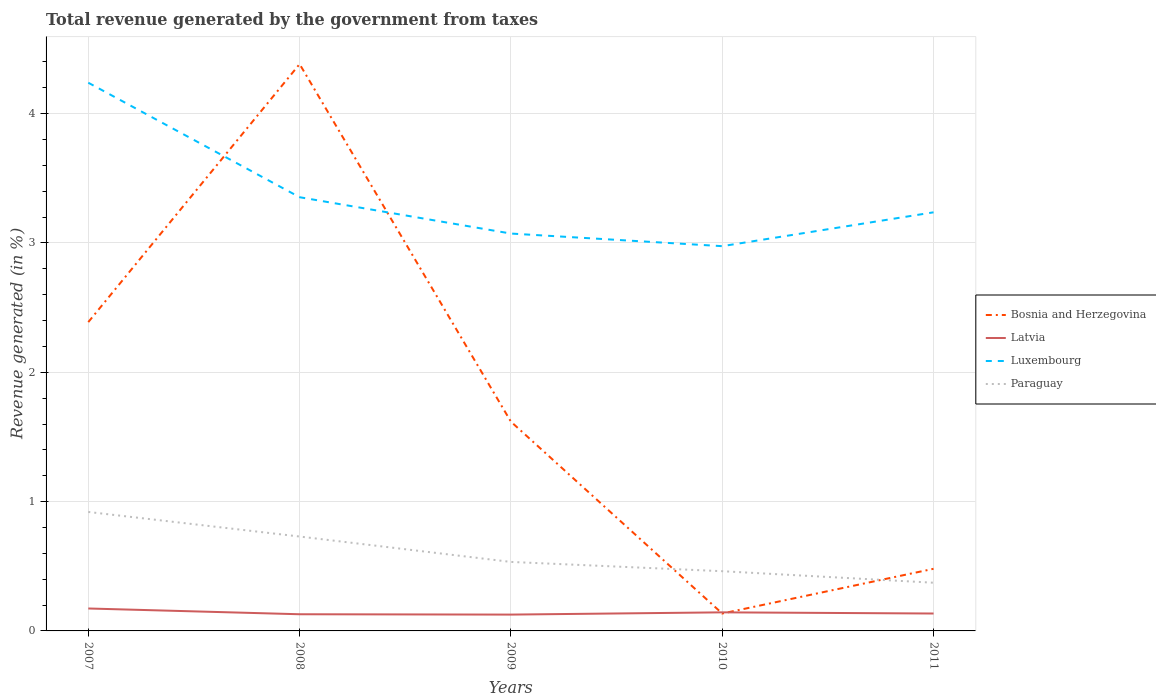Does the line corresponding to Luxembourg intersect with the line corresponding to Bosnia and Herzegovina?
Make the answer very short. Yes. Is the number of lines equal to the number of legend labels?
Ensure brevity in your answer.  Yes. Across all years, what is the maximum total revenue generated in Paraguay?
Ensure brevity in your answer.  0.37. What is the total total revenue generated in Latvia in the graph?
Provide a short and direct response. 0.04. What is the difference between the highest and the second highest total revenue generated in Latvia?
Your answer should be compact. 0.05. What is the difference between the highest and the lowest total revenue generated in Paraguay?
Ensure brevity in your answer.  2. Is the total revenue generated in Latvia strictly greater than the total revenue generated in Paraguay over the years?
Your answer should be very brief. Yes. How many lines are there?
Your response must be concise. 4. What is the difference between two consecutive major ticks on the Y-axis?
Your response must be concise. 1. Does the graph contain any zero values?
Your answer should be compact. No. Does the graph contain grids?
Provide a succinct answer. Yes. How many legend labels are there?
Offer a terse response. 4. How are the legend labels stacked?
Give a very brief answer. Vertical. What is the title of the graph?
Your answer should be very brief. Total revenue generated by the government from taxes. What is the label or title of the X-axis?
Keep it short and to the point. Years. What is the label or title of the Y-axis?
Your answer should be very brief. Revenue generated (in %). What is the Revenue generated (in %) of Bosnia and Herzegovina in 2007?
Provide a succinct answer. 2.39. What is the Revenue generated (in %) of Latvia in 2007?
Offer a terse response. 0.17. What is the Revenue generated (in %) of Luxembourg in 2007?
Provide a succinct answer. 4.24. What is the Revenue generated (in %) in Paraguay in 2007?
Your answer should be very brief. 0.92. What is the Revenue generated (in %) in Bosnia and Herzegovina in 2008?
Your response must be concise. 4.38. What is the Revenue generated (in %) of Latvia in 2008?
Keep it short and to the point. 0.13. What is the Revenue generated (in %) in Luxembourg in 2008?
Your answer should be compact. 3.35. What is the Revenue generated (in %) in Paraguay in 2008?
Provide a succinct answer. 0.73. What is the Revenue generated (in %) in Bosnia and Herzegovina in 2009?
Offer a very short reply. 1.62. What is the Revenue generated (in %) of Latvia in 2009?
Your response must be concise. 0.13. What is the Revenue generated (in %) in Luxembourg in 2009?
Your answer should be compact. 3.07. What is the Revenue generated (in %) in Paraguay in 2009?
Provide a short and direct response. 0.53. What is the Revenue generated (in %) of Bosnia and Herzegovina in 2010?
Your answer should be compact. 0.13. What is the Revenue generated (in %) in Latvia in 2010?
Make the answer very short. 0.14. What is the Revenue generated (in %) of Luxembourg in 2010?
Ensure brevity in your answer.  2.98. What is the Revenue generated (in %) of Paraguay in 2010?
Make the answer very short. 0.46. What is the Revenue generated (in %) of Bosnia and Herzegovina in 2011?
Your answer should be very brief. 0.48. What is the Revenue generated (in %) in Latvia in 2011?
Offer a very short reply. 0.13. What is the Revenue generated (in %) in Luxembourg in 2011?
Make the answer very short. 3.24. What is the Revenue generated (in %) in Paraguay in 2011?
Offer a very short reply. 0.37. Across all years, what is the maximum Revenue generated (in %) of Bosnia and Herzegovina?
Offer a very short reply. 4.38. Across all years, what is the maximum Revenue generated (in %) in Latvia?
Give a very brief answer. 0.17. Across all years, what is the maximum Revenue generated (in %) of Luxembourg?
Your response must be concise. 4.24. Across all years, what is the maximum Revenue generated (in %) in Paraguay?
Make the answer very short. 0.92. Across all years, what is the minimum Revenue generated (in %) of Bosnia and Herzegovina?
Make the answer very short. 0.13. Across all years, what is the minimum Revenue generated (in %) in Latvia?
Provide a succinct answer. 0.13. Across all years, what is the minimum Revenue generated (in %) in Luxembourg?
Ensure brevity in your answer.  2.98. Across all years, what is the minimum Revenue generated (in %) in Paraguay?
Make the answer very short. 0.37. What is the total Revenue generated (in %) in Bosnia and Herzegovina in the graph?
Give a very brief answer. 9. What is the total Revenue generated (in %) in Latvia in the graph?
Offer a very short reply. 0.71. What is the total Revenue generated (in %) of Luxembourg in the graph?
Give a very brief answer. 16.88. What is the total Revenue generated (in %) of Paraguay in the graph?
Make the answer very short. 3.02. What is the difference between the Revenue generated (in %) of Bosnia and Herzegovina in 2007 and that in 2008?
Your answer should be compact. -2. What is the difference between the Revenue generated (in %) in Latvia in 2007 and that in 2008?
Offer a very short reply. 0.04. What is the difference between the Revenue generated (in %) in Luxembourg in 2007 and that in 2008?
Provide a short and direct response. 0.89. What is the difference between the Revenue generated (in %) of Paraguay in 2007 and that in 2008?
Your answer should be very brief. 0.19. What is the difference between the Revenue generated (in %) of Bosnia and Herzegovina in 2007 and that in 2009?
Make the answer very short. 0.77. What is the difference between the Revenue generated (in %) of Latvia in 2007 and that in 2009?
Your answer should be very brief. 0.05. What is the difference between the Revenue generated (in %) of Luxembourg in 2007 and that in 2009?
Your answer should be compact. 1.17. What is the difference between the Revenue generated (in %) in Paraguay in 2007 and that in 2009?
Keep it short and to the point. 0.39. What is the difference between the Revenue generated (in %) of Bosnia and Herzegovina in 2007 and that in 2010?
Your answer should be compact. 2.25. What is the difference between the Revenue generated (in %) in Latvia in 2007 and that in 2010?
Make the answer very short. 0.03. What is the difference between the Revenue generated (in %) in Luxembourg in 2007 and that in 2010?
Offer a terse response. 1.26. What is the difference between the Revenue generated (in %) of Paraguay in 2007 and that in 2010?
Provide a short and direct response. 0.46. What is the difference between the Revenue generated (in %) in Bosnia and Herzegovina in 2007 and that in 2011?
Keep it short and to the point. 1.91. What is the difference between the Revenue generated (in %) of Latvia in 2007 and that in 2011?
Make the answer very short. 0.04. What is the difference between the Revenue generated (in %) in Luxembourg in 2007 and that in 2011?
Offer a terse response. 1. What is the difference between the Revenue generated (in %) of Paraguay in 2007 and that in 2011?
Provide a short and direct response. 0.55. What is the difference between the Revenue generated (in %) of Bosnia and Herzegovina in 2008 and that in 2009?
Provide a short and direct response. 2.76. What is the difference between the Revenue generated (in %) of Latvia in 2008 and that in 2009?
Give a very brief answer. 0. What is the difference between the Revenue generated (in %) in Luxembourg in 2008 and that in 2009?
Provide a succinct answer. 0.28. What is the difference between the Revenue generated (in %) of Paraguay in 2008 and that in 2009?
Your answer should be very brief. 0.2. What is the difference between the Revenue generated (in %) in Bosnia and Herzegovina in 2008 and that in 2010?
Make the answer very short. 4.25. What is the difference between the Revenue generated (in %) in Latvia in 2008 and that in 2010?
Ensure brevity in your answer.  -0.01. What is the difference between the Revenue generated (in %) of Luxembourg in 2008 and that in 2010?
Give a very brief answer. 0.38. What is the difference between the Revenue generated (in %) of Paraguay in 2008 and that in 2010?
Provide a succinct answer. 0.27. What is the difference between the Revenue generated (in %) in Bosnia and Herzegovina in 2008 and that in 2011?
Provide a succinct answer. 3.9. What is the difference between the Revenue generated (in %) of Latvia in 2008 and that in 2011?
Give a very brief answer. -0.01. What is the difference between the Revenue generated (in %) in Luxembourg in 2008 and that in 2011?
Offer a very short reply. 0.12. What is the difference between the Revenue generated (in %) of Paraguay in 2008 and that in 2011?
Provide a short and direct response. 0.36. What is the difference between the Revenue generated (in %) in Bosnia and Herzegovina in 2009 and that in 2010?
Your answer should be compact. 1.48. What is the difference between the Revenue generated (in %) of Latvia in 2009 and that in 2010?
Your answer should be compact. -0.02. What is the difference between the Revenue generated (in %) in Luxembourg in 2009 and that in 2010?
Offer a terse response. 0.1. What is the difference between the Revenue generated (in %) of Paraguay in 2009 and that in 2010?
Make the answer very short. 0.07. What is the difference between the Revenue generated (in %) in Bosnia and Herzegovina in 2009 and that in 2011?
Ensure brevity in your answer.  1.14. What is the difference between the Revenue generated (in %) of Latvia in 2009 and that in 2011?
Give a very brief answer. -0.01. What is the difference between the Revenue generated (in %) of Luxembourg in 2009 and that in 2011?
Offer a terse response. -0.16. What is the difference between the Revenue generated (in %) of Paraguay in 2009 and that in 2011?
Offer a very short reply. 0.16. What is the difference between the Revenue generated (in %) of Bosnia and Herzegovina in 2010 and that in 2011?
Provide a succinct answer. -0.35. What is the difference between the Revenue generated (in %) in Latvia in 2010 and that in 2011?
Offer a very short reply. 0.01. What is the difference between the Revenue generated (in %) of Luxembourg in 2010 and that in 2011?
Ensure brevity in your answer.  -0.26. What is the difference between the Revenue generated (in %) of Paraguay in 2010 and that in 2011?
Your response must be concise. 0.09. What is the difference between the Revenue generated (in %) of Bosnia and Herzegovina in 2007 and the Revenue generated (in %) of Latvia in 2008?
Make the answer very short. 2.26. What is the difference between the Revenue generated (in %) of Bosnia and Herzegovina in 2007 and the Revenue generated (in %) of Luxembourg in 2008?
Ensure brevity in your answer.  -0.97. What is the difference between the Revenue generated (in %) of Bosnia and Herzegovina in 2007 and the Revenue generated (in %) of Paraguay in 2008?
Make the answer very short. 1.66. What is the difference between the Revenue generated (in %) in Latvia in 2007 and the Revenue generated (in %) in Luxembourg in 2008?
Offer a terse response. -3.18. What is the difference between the Revenue generated (in %) of Latvia in 2007 and the Revenue generated (in %) of Paraguay in 2008?
Provide a short and direct response. -0.56. What is the difference between the Revenue generated (in %) in Luxembourg in 2007 and the Revenue generated (in %) in Paraguay in 2008?
Offer a terse response. 3.51. What is the difference between the Revenue generated (in %) in Bosnia and Herzegovina in 2007 and the Revenue generated (in %) in Latvia in 2009?
Offer a terse response. 2.26. What is the difference between the Revenue generated (in %) of Bosnia and Herzegovina in 2007 and the Revenue generated (in %) of Luxembourg in 2009?
Give a very brief answer. -0.68. What is the difference between the Revenue generated (in %) of Bosnia and Herzegovina in 2007 and the Revenue generated (in %) of Paraguay in 2009?
Ensure brevity in your answer.  1.85. What is the difference between the Revenue generated (in %) of Latvia in 2007 and the Revenue generated (in %) of Luxembourg in 2009?
Make the answer very short. -2.9. What is the difference between the Revenue generated (in %) in Latvia in 2007 and the Revenue generated (in %) in Paraguay in 2009?
Offer a terse response. -0.36. What is the difference between the Revenue generated (in %) in Luxembourg in 2007 and the Revenue generated (in %) in Paraguay in 2009?
Provide a succinct answer. 3.71. What is the difference between the Revenue generated (in %) in Bosnia and Herzegovina in 2007 and the Revenue generated (in %) in Latvia in 2010?
Offer a terse response. 2.24. What is the difference between the Revenue generated (in %) of Bosnia and Herzegovina in 2007 and the Revenue generated (in %) of Luxembourg in 2010?
Your answer should be very brief. -0.59. What is the difference between the Revenue generated (in %) in Bosnia and Herzegovina in 2007 and the Revenue generated (in %) in Paraguay in 2010?
Provide a short and direct response. 1.93. What is the difference between the Revenue generated (in %) in Latvia in 2007 and the Revenue generated (in %) in Luxembourg in 2010?
Your response must be concise. -2.8. What is the difference between the Revenue generated (in %) in Latvia in 2007 and the Revenue generated (in %) in Paraguay in 2010?
Ensure brevity in your answer.  -0.29. What is the difference between the Revenue generated (in %) in Luxembourg in 2007 and the Revenue generated (in %) in Paraguay in 2010?
Make the answer very short. 3.78. What is the difference between the Revenue generated (in %) of Bosnia and Herzegovina in 2007 and the Revenue generated (in %) of Latvia in 2011?
Your response must be concise. 2.25. What is the difference between the Revenue generated (in %) in Bosnia and Herzegovina in 2007 and the Revenue generated (in %) in Luxembourg in 2011?
Offer a very short reply. -0.85. What is the difference between the Revenue generated (in %) in Bosnia and Herzegovina in 2007 and the Revenue generated (in %) in Paraguay in 2011?
Your answer should be very brief. 2.02. What is the difference between the Revenue generated (in %) in Latvia in 2007 and the Revenue generated (in %) in Luxembourg in 2011?
Give a very brief answer. -3.06. What is the difference between the Revenue generated (in %) of Latvia in 2007 and the Revenue generated (in %) of Paraguay in 2011?
Provide a succinct answer. -0.2. What is the difference between the Revenue generated (in %) of Luxembourg in 2007 and the Revenue generated (in %) of Paraguay in 2011?
Provide a succinct answer. 3.87. What is the difference between the Revenue generated (in %) in Bosnia and Herzegovina in 2008 and the Revenue generated (in %) in Latvia in 2009?
Keep it short and to the point. 4.26. What is the difference between the Revenue generated (in %) in Bosnia and Herzegovina in 2008 and the Revenue generated (in %) in Luxembourg in 2009?
Give a very brief answer. 1.31. What is the difference between the Revenue generated (in %) in Bosnia and Herzegovina in 2008 and the Revenue generated (in %) in Paraguay in 2009?
Make the answer very short. 3.85. What is the difference between the Revenue generated (in %) of Latvia in 2008 and the Revenue generated (in %) of Luxembourg in 2009?
Give a very brief answer. -2.94. What is the difference between the Revenue generated (in %) of Latvia in 2008 and the Revenue generated (in %) of Paraguay in 2009?
Make the answer very short. -0.4. What is the difference between the Revenue generated (in %) in Luxembourg in 2008 and the Revenue generated (in %) in Paraguay in 2009?
Keep it short and to the point. 2.82. What is the difference between the Revenue generated (in %) of Bosnia and Herzegovina in 2008 and the Revenue generated (in %) of Latvia in 2010?
Offer a terse response. 4.24. What is the difference between the Revenue generated (in %) in Bosnia and Herzegovina in 2008 and the Revenue generated (in %) in Luxembourg in 2010?
Ensure brevity in your answer.  1.41. What is the difference between the Revenue generated (in %) in Bosnia and Herzegovina in 2008 and the Revenue generated (in %) in Paraguay in 2010?
Your answer should be compact. 3.92. What is the difference between the Revenue generated (in %) in Latvia in 2008 and the Revenue generated (in %) in Luxembourg in 2010?
Give a very brief answer. -2.85. What is the difference between the Revenue generated (in %) of Latvia in 2008 and the Revenue generated (in %) of Paraguay in 2010?
Keep it short and to the point. -0.33. What is the difference between the Revenue generated (in %) of Luxembourg in 2008 and the Revenue generated (in %) of Paraguay in 2010?
Keep it short and to the point. 2.89. What is the difference between the Revenue generated (in %) in Bosnia and Herzegovina in 2008 and the Revenue generated (in %) in Latvia in 2011?
Provide a succinct answer. 4.25. What is the difference between the Revenue generated (in %) in Bosnia and Herzegovina in 2008 and the Revenue generated (in %) in Luxembourg in 2011?
Ensure brevity in your answer.  1.15. What is the difference between the Revenue generated (in %) of Bosnia and Herzegovina in 2008 and the Revenue generated (in %) of Paraguay in 2011?
Your response must be concise. 4.01. What is the difference between the Revenue generated (in %) of Latvia in 2008 and the Revenue generated (in %) of Luxembourg in 2011?
Ensure brevity in your answer.  -3.11. What is the difference between the Revenue generated (in %) in Latvia in 2008 and the Revenue generated (in %) in Paraguay in 2011?
Offer a very short reply. -0.24. What is the difference between the Revenue generated (in %) in Luxembourg in 2008 and the Revenue generated (in %) in Paraguay in 2011?
Provide a succinct answer. 2.98. What is the difference between the Revenue generated (in %) in Bosnia and Herzegovina in 2009 and the Revenue generated (in %) in Latvia in 2010?
Provide a succinct answer. 1.47. What is the difference between the Revenue generated (in %) of Bosnia and Herzegovina in 2009 and the Revenue generated (in %) of Luxembourg in 2010?
Make the answer very short. -1.36. What is the difference between the Revenue generated (in %) of Bosnia and Herzegovina in 2009 and the Revenue generated (in %) of Paraguay in 2010?
Offer a terse response. 1.16. What is the difference between the Revenue generated (in %) in Latvia in 2009 and the Revenue generated (in %) in Luxembourg in 2010?
Give a very brief answer. -2.85. What is the difference between the Revenue generated (in %) in Latvia in 2009 and the Revenue generated (in %) in Paraguay in 2010?
Provide a short and direct response. -0.34. What is the difference between the Revenue generated (in %) of Luxembourg in 2009 and the Revenue generated (in %) of Paraguay in 2010?
Ensure brevity in your answer.  2.61. What is the difference between the Revenue generated (in %) in Bosnia and Herzegovina in 2009 and the Revenue generated (in %) in Latvia in 2011?
Your answer should be compact. 1.48. What is the difference between the Revenue generated (in %) of Bosnia and Herzegovina in 2009 and the Revenue generated (in %) of Luxembourg in 2011?
Make the answer very short. -1.62. What is the difference between the Revenue generated (in %) in Bosnia and Herzegovina in 2009 and the Revenue generated (in %) in Paraguay in 2011?
Ensure brevity in your answer.  1.25. What is the difference between the Revenue generated (in %) in Latvia in 2009 and the Revenue generated (in %) in Luxembourg in 2011?
Offer a very short reply. -3.11. What is the difference between the Revenue generated (in %) in Latvia in 2009 and the Revenue generated (in %) in Paraguay in 2011?
Your response must be concise. -0.25. What is the difference between the Revenue generated (in %) of Luxembourg in 2009 and the Revenue generated (in %) of Paraguay in 2011?
Offer a very short reply. 2.7. What is the difference between the Revenue generated (in %) of Bosnia and Herzegovina in 2010 and the Revenue generated (in %) of Latvia in 2011?
Keep it short and to the point. 0. What is the difference between the Revenue generated (in %) in Bosnia and Herzegovina in 2010 and the Revenue generated (in %) in Luxembourg in 2011?
Offer a terse response. -3.1. What is the difference between the Revenue generated (in %) in Bosnia and Herzegovina in 2010 and the Revenue generated (in %) in Paraguay in 2011?
Provide a short and direct response. -0.24. What is the difference between the Revenue generated (in %) in Latvia in 2010 and the Revenue generated (in %) in Luxembourg in 2011?
Your answer should be very brief. -3.09. What is the difference between the Revenue generated (in %) of Latvia in 2010 and the Revenue generated (in %) of Paraguay in 2011?
Offer a terse response. -0.23. What is the difference between the Revenue generated (in %) of Luxembourg in 2010 and the Revenue generated (in %) of Paraguay in 2011?
Your answer should be compact. 2.6. What is the average Revenue generated (in %) in Bosnia and Herzegovina per year?
Keep it short and to the point. 1.8. What is the average Revenue generated (in %) in Latvia per year?
Ensure brevity in your answer.  0.14. What is the average Revenue generated (in %) of Luxembourg per year?
Give a very brief answer. 3.38. What is the average Revenue generated (in %) of Paraguay per year?
Provide a short and direct response. 0.6. In the year 2007, what is the difference between the Revenue generated (in %) in Bosnia and Herzegovina and Revenue generated (in %) in Latvia?
Your answer should be very brief. 2.21. In the year 2007, what is the difference between the Revenue generated (in %) of Bosnia and Herzegovina and Revenue generated (in %) of Luxembourg?
Your answer should be compact. -1.85. In the year 2007, what is the difference between the Revenue generated (in %) in Bosnia and Herzegovina and Revenue generated (in %) in Paraguay?
Your response must be concise. 1.47. In the year 2007, what is the difference between the Revenue generated (in %) of Latvia and Revenue generated (in %) of Luxembourg?
Make the answer very short. -4.07. In the year 2007, what is the difference between the Revenue generated (in %) of Latvia and Revenue generated (in %) of Paraguay?
Your answer should be very brief. -0.75. In the year 2007, what is the difference between the Revenue generated (in %) in Luxembourg and Revenue generated (in %) in Paraguay?
Give a very brief answer. 3.32. In the year 2008, what is the difference between the Revenue generated (in %) in Bosnia and Herzegovina and Revenue generated (in %) in Latvia?
Provide a short and direct response. 4.25. In the year 2008, what is the difference between the Revenue generated (in %) of Bosnia and Herzegovina and Revenue generated (in %) of Luxembourg?
Your response must be concise. 1.03. In the year 2008, what is the difference between the Revenue generated (in %) of Bosnia and Herzegovina and Revenue generated (in %) of Paraguay?
Keep it short and to the point. 3.65. In the year 2008, what is the difference between the Revenue generated (in %) in Latvia and Revenue generated (in %) in Luxembourg?
Offer a terse response. -3.22. In the year 2008, what is the difference between the Revenue generated (in %) in Latvia and Revenue generated (in %) in Paraguay?
Ensure brevity in your answer.  -0.6. In the year 2008, what is the difference between the Revenue generated (in %) in Luxembourg and Revenue generated (in %) in Paraguay?
Provide a succinct answer. 2.62. In the year 2009, what is the difference between the Revenue generated (in %) of Bosnia and Herzegovina and Revenue generated (in %) of Latvia?
Provide a succinct answer. 1.49. In the year 2009, what is the difference between the Revenue generated (in %) of Bosnia and Herzegovina and Revenue generated (in %) of Luxembourg?
Your answer should be very brief. -1.45. In the year 2009, what is the difference between the Revenue generated (in %) of Bosnia and Herzegovina and Revenue generated (in %) of Paraguay?
Provide a short and direct response. 1.08. In the year 2009, what is the difference between the Revenue generated (in %) in Latvia and Revenue generated (in %) in Luxembourg?
Provide a short and direct response. -2.95. In the year 2009, what is the difference between the Revenue generated (in %) of Latvia and Revenue generated (in %) of Paraguay?
Your answer should be very brief. -0.41. In the year 2009, what is the difference between the Revenue generated (in %) of Luxembourg and Revenue generated (in %) of Paraguay?
Make the answer very short. 2.54. In the year 2010, what is the difference between the Revenue generated (in %) in Bosnia and Herzegovina and Revenue generated (in %) in Latvia?
Provide a succinct answer. -0.01. In the year 2010, what is the difference between the Revenue generated (in %) of Bosnia and Herzegovina and Revenue generated (in %) of Luxembourg?
Keep it short and to the point. -2.84. In the year 2010, what is the difference between the Revenue generated (in %) in Bosnia and Herzegovina and Revenue generated (in %) in Paraguay?
Provide a succinct answer. -0.33. In the year 2010, what is the difference between the Revenue generated (in %) of Latvia and Revenue generated (in %) of Luxembourg?
Your answer should be very brief. -2.83. In the year 2010, what is the difference between the Revenue generated (in %) of Latvia and Revenue generated (in %) of Paraguay?
Give a very brief answer. -0.32. In the year 2010, what is the difference between the Revenue generated (in %) in Luxembourg and Revenue generated (in %) in Paraguay?
Give a very brief answer. 2.51. In the year 2011, what is the difference between the Revenue generated (in %) of Bosnia and Herzegovina and Revenue generated (in %) of Latvia?
Give a very brief answer. 0.35. In the year 2011, what is the difference between the Revenue generated (in %) of Bosnia and Herzegovina and Revenue generated (in %) of Luxembourg?
Offer a terse response. -2.76. In the year 2011, what is the difference between the Revenue generated (in %) in Bosnia and Herzegovina and Revenue generated (in %) in Paraguay?
Ensure brevity in your answer.  0.11. In the year 2011, what is the difference between the Revenue generated (in %) in Latvia and Revenue generated (in %) in Luxembourg?
Ensure brevity in your answer.  -3.1. In the year 2011, what is the difference between the Revenue generated (in %) of Latvia and Revenue generated (in %) of Paraguay?
Your answer should be compact. -0.24. In the year 2011, what is the difference between the Revenue generated (in %) of Luxembourg and Revenue generated (in %) of Paraguay?
Offer a very short reply. 2.86. What is the ratio of the Revenue generated (in %) of Bosnia and Herzegovina in 2007 to that in 2008?
Provide a short and direct response. 0.54. What is the ratio of the Revenue generated (in %) in Latvia in 2007 to that in 2008?
Keep it short and to the point. 1.35. What is the ratio of the Revenue generated (in %) of Luxembourg in 2007 to that in 2008?
Provide a short and direct response. 1.26. What is the ratio of the Revenue generated (in %) of Paraguay in 2007 to that in 2008?
Make the answer very short. 1.26. What is the ratio of the Revenue generated (in %) in Bosnia and Herzegovina in 2007 to that in 2009?
Your answer should be very brief. 1.48. What is the ratio of the Revenue generated (in %) in Latvia in 2007 to that in 2009?
Make the answer very short. 1.37. What is the ratio of the Revenue generated (in %) of Luxembourg in 2007 to that in 2009?
Offer a very short reply. 1.38. What is the ratio of the Revenue generated (in %) in Paraguay in 2007 to that in 2009?
Make the answer very short. 1.72. What is the ratio of the Revenue generated (in %) of Bosnia and Herzegovina in 2007 to that in 2010?
Offer a very short reply. 17.73. What is the ratio of the Revenue generated (in %) of Latvia in 2007 to that in 2010?
Ensure brevity in your answer.  1.21. What is the ratio of the Revenue generated (in %) in Luxembourg in 2007 to that in 2010?
Your answer should be compact. 1.42. What is the ratio of the Revenue generated (in %) in Paraguay in 2007 to that in 2010?
Your response must be concise. 1.99. What is the ratio of the Revenue generated (in %) of Bosnia and Herzegovina in 2007 to that in 2011?
Your answer should be compact. 4.97. What is the ratio of the Revenue generated (in %) in Latvia in 2007 to that in 2011?
Keep it short and to the point. 1.29. What is the ratio of the Revenue generated (in %) of Luxembourg in 2007 to that in 2011?
Your answer should be compact. 1.31. What is the ratio of the Revenue generated (in %) in Paraguay in 2007 to that in 2011?
Provide a succinct answer. 2.47. What is the ratio of the Revenue generated (in %) of Bosnia and Herzegovina in 2008 to that in 2009?
Give a very brief answer. 2.71. What is the ratio of the Revenue generated (in %) of Latvia in 2008 to that in 2009?
Make the answer very short. 1.02. What is the ratio of the Revenue generated (in %) of Luxembourg in 2008 to that in 2009?
Offer a terse response. 1.09. What is the ratio of the Revenue generated (in %) of Paraguay in 2008 to that in 2009?
Offer a terse response. 1.37. What is the ratio of the Revenue generated (in %) in Bosnia and Herzegovina in 2008 to that in 2010?
Make the answer very short. 32.55. What is the ratio of the Revenue generated (in %) in Latvia in 2008 to that in 2010?
Offer a very short reply. 0.9. What is the ratio of the Revenue generated (in %) of Luxembourg in 2008 to that in 2010?
Offer a terse response. 1.13. What is the ratio of the Revenue generated (in %) in Paraguay in 2008 to that in 2010?
Your answer should be very brief. 1.58. What is the ratio of the Revenue generated (in %) of Bosnia and Herzegovina in 2008 to that in 2011?
Your answer should be very brief. 9.12. What is the ratio of the Revenue generated (in %) of Latvia in 2008 to that in 2011?
Give a very brief answer. 0.96. What is the ratio of the Revenue generated (in %) in Luxembourg in 2008 to that in 2011?
Make the answer very short. 1.04. What is the ratio of the Revenue generated (in %) in Paraguay in 2008 to that in 2011?
Make the answer very short. 1.96. What is the ratio of the Revenue generated (in %) of Bosnia and Herzegovina in 2009 to that in 2010?
Your response must be concise. 12.02. What is the ratio of the Revenue generated (in %) of Latvia in 2009 to that in 2010?
Keep it short and to the point. 0.88. What is the ratio of the Revenue generated (in %) of Luxembourg in 2009 to that in 2010?
Offer a terse response. 1.03. What is the ratio of the Revenue generated (in %) in Paraguay in 2009 to that in 2010?
Provide a short and direct response. 1.16. What is the ratio of the Revenue generated (in %) of Bosnia and Herzegovina in 2009 to that in 2011?
Provide a succinct answer. 3.37. What is the ratio of the Revenue generated (in %) of Latvia in 2009 to that in 2011?
Give a very brief answer. 0.94. What is the ratio of the Revenue generated (in %) in Luxembourg in 2009 to that in 2011?
Your response must be concise. 0.95. What is the ratio of the Revenue generated (in %) in Paraguay in 2009 to that in 2011?
Provide a succinct answer. 1.43. What is the ratio of the Revenue generated (in %) in Bosnia and Herzegovina in 2010 to that in 2011?
Offer a very short reply. 0.28. What is the ratio of the Revenue generated (in %) in Latvia in 2010 to that in 2011?
Give a very brief answer. 1.07. What is the ratio of the Revenue generated (in %) in Luxembourg in 2010 to that in 2011?
Give a very brief answer. 0.92. What is the ratio of the Revenue generated (in %) of Paraguay in 2010 to that in 2011?
Provide a short and direct response. 1.24. What is the difference between the highest and the second highest Revenue generated (in %) in Bosnia and Herzegovina?
Your answer should be very brief. 2. What is the difference between the highest and the second highest Revenue generated (in %) of Latvia?
Offer a very short reply. 0.03. What is the difference between the highest and the second highest Revenue generated (in %) of Luxembourg?
Your answer should be very brief. 0.89. What is the difference between the highest and the second highest Revenue generated (in %) in Paraguay?
Your response must be concise. 0.19. What is the difference between the highest and the lowest Revenue generated (in %) of Bosnia and Herzegovina?
Offer a very short reply. 4.25. What is the difference between the highest and the lowest Revenue generated (in %) in Latvia?
Ensure brevity in your answer.  0.05. What is the difference between the highest and the lowest Revenue generated (in %) of Luxembourg?
Ensure brevity in your answer.  1.26. What is the difference between the highest and the lowest Revenue generated (in %) in Paraguay?
Keep it short and to the point. 0.55. 